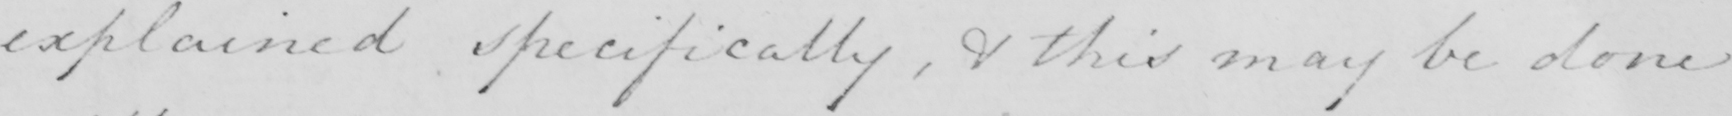Please provide the text content of this handwritten line. explained specifically , & this may be done 